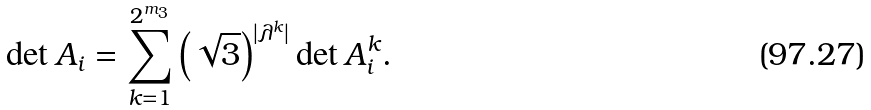Convert formula to latex. <formula><loc_0><loc_0><loc_500><loc_500>\det A _ { i } = \sum _ { k = 1 } ^ { 2 ^ { m _ { 3 } } } \left ( \sqrt { 3 } \right ) ^ { | \lambda ^ { k } | } \det A _ { i } ^ { k } .</formula> 